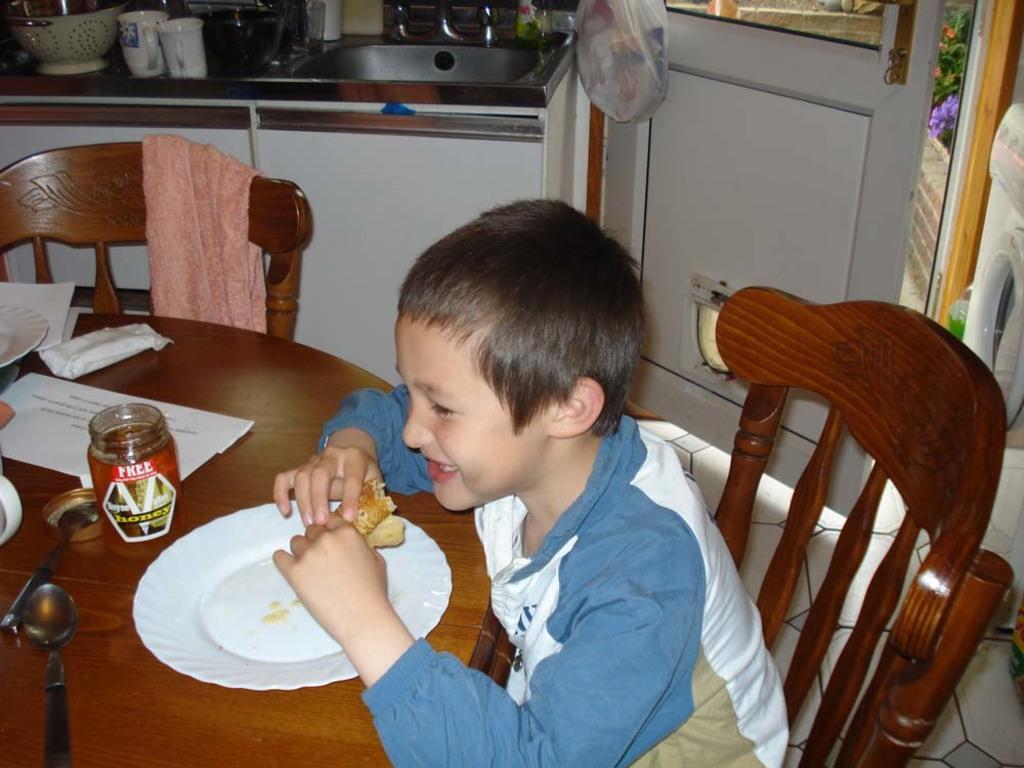How would you summarize this image in a sentence or two? In this picture we can see a boy sitting on the chair in front of him there is a table on the table we have bottle plate spoons and some papers there is another chair decide hand back side we can see a door or and some cups, bags. 